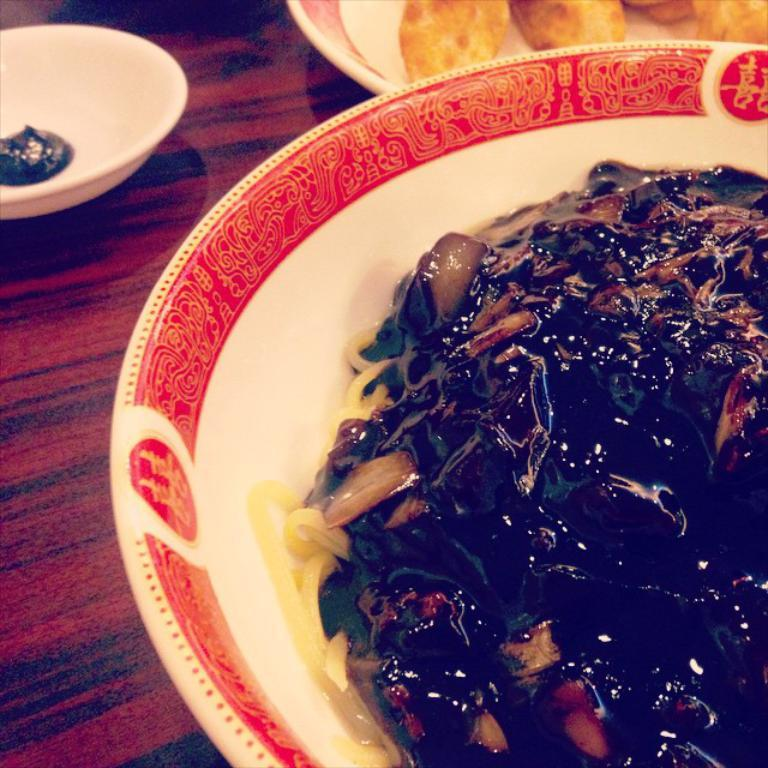What piece of furniture is present in the image? There is a table in the image. How many plates are on the table? There are two plates on the table. What is in the plates? There is food in the plates. What else is on the table besides the plates? There is a bowl on the table. What is in the bowl? There is food in the bowl. What type of frogs can be seen in the image? There are no frogs present in the image. How does the anger in the image manifest itself? There is no indication of anger in the image; it only shows a table with plates and a bowl containing food. 